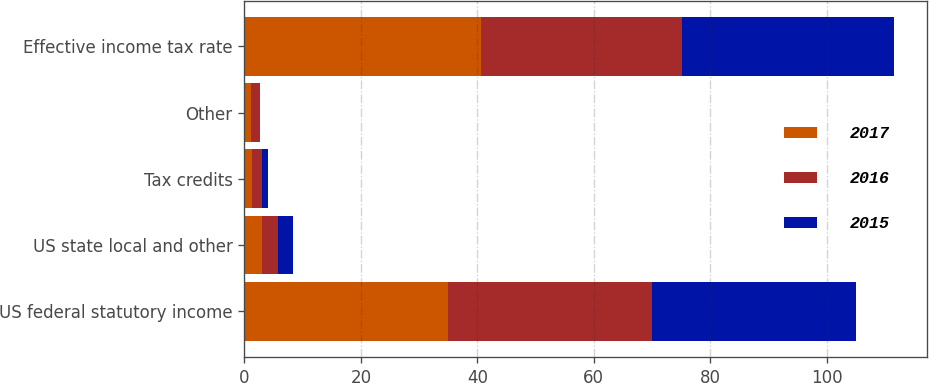<chart> <loc_0><loc_0><loc_500><loc_500><stacked_bar_chart><ecel><fcel>US federal statutory income<fcel>US state local and other<fcel>Tax credits<fcel>Other<fcel>Effective income tax rate<nl><fcel>2017<fcel>35<fcel>3.1<fcel>1.3<fcel>1.2<fcel>40.7<nl><fcel>2016<fcel>35<fcel>2.7<fcel>1.8<fcel>1.4<fcel>34.5<nl><fcel>2015<fcel>35<fcel>2.5<fcel>1<fcel>0.1<fcel>36.4<nl></chart> 